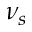Convert formula to latex. <formula><loc_0><loc_0><loc_500><loc_500>\nu _ { s }</formula> 